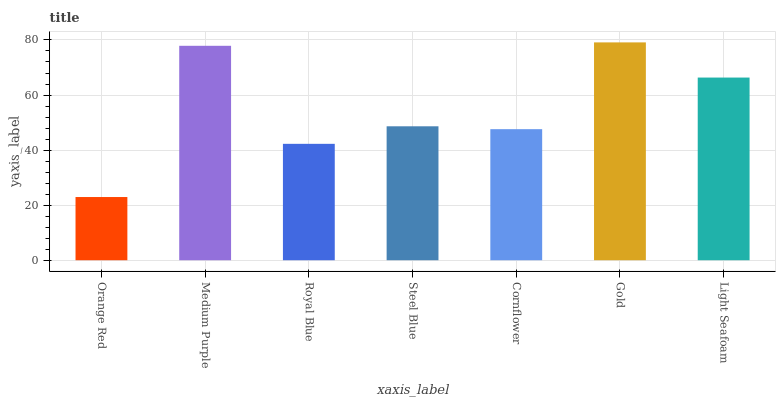Is Orange Red the minimum?
Answer yes or no. Yes. Is Gold the maximum?
Answer yes or no. Yes. Is Medium Purple the minimum?
Answer yes or no. No. Is Medium Purple the maximum?
Answer yes or no. No. Is Medium Purple greater than Orange Red?
Answer yes or no. Yes. Is Orange Red less than Medium Purple?
Answer yes or no. Yes. Is Orange Red greater than Medium Purple?
Answer yes or no. No. Is Medium Purple less than Orange Red?
Answer yes or no. No. Is Steel Blue the high median?
Answer yes or no. Yes. Is Steel Blue the low median?
Answer yes or no. Yes. Is Cornflower the high median?
Answer yes or no. No. Is Gold the low median?
Answer yes or no. No. 